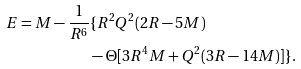<formula> <loc_0><loc_0><loc_500><loc_500>E = M - \frac { 1 } { R ^ { 6 } } & \{ R ^ { 2 } Q ^ { 2 } ( 2 R - 5 M ) \\ & - \Theta [ 3 R ^ { 4 } M + Q ^ { 2 } ( 3 R - 1 4 M ) ] \} .</formula> 